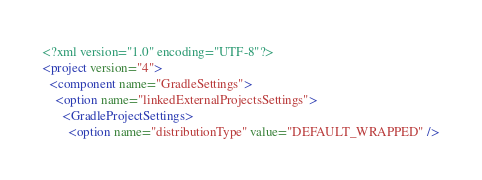Convert code to text. <code><loc_0><loc_0><loc_500><loc_500><_XML_><?xml version="1.0" encoding="UTF-8"?>
<project version="4">
  <component name="GradleSettings">
    <option name="linkedExternalProjectsSettings">
      <GradleProjectSettings>
        <option name="distributionType" value="DEFAULT_WRAPPED" /></code> 